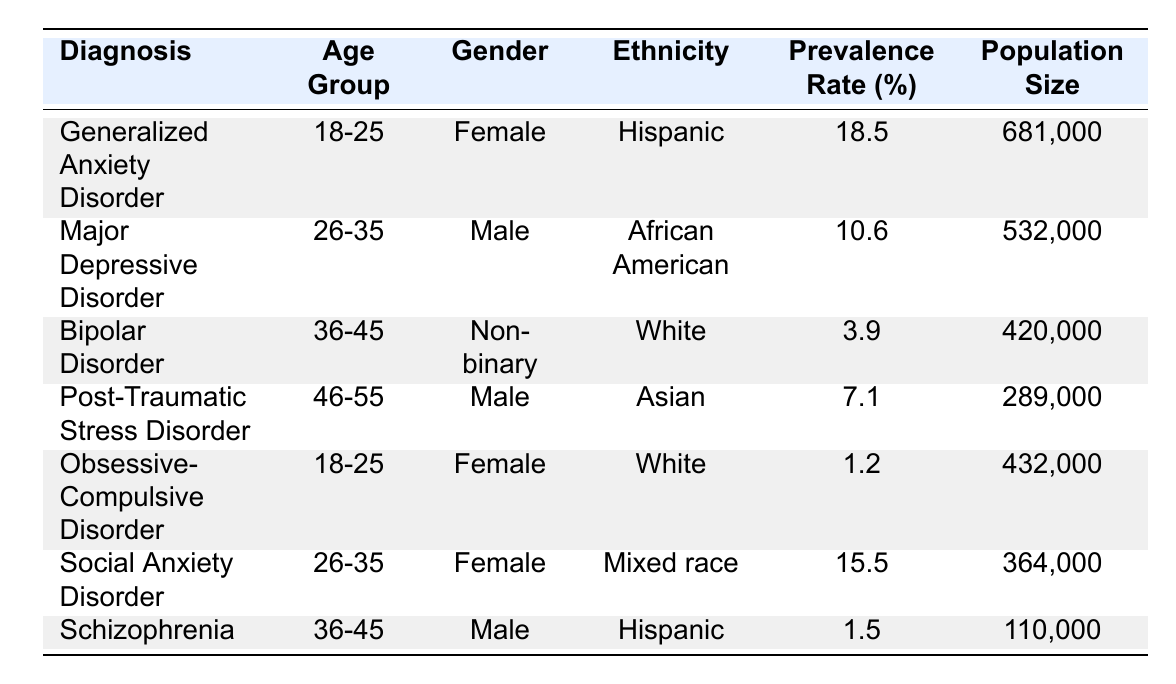What is the prevalence rate for Generalized Anxiety Disorder? The prevalence rate for Generalized Anxiety Disorder can be found in the table under the "Prevalence Rate (%)" column for the corresponding diagnosis. It shows as 18.5% for the age group 18-25, female, Hispanic population.
Answer: 18.5% How many individuals are diagnosed with Major Depressive Disorder in the 26-35 age group? The table indicates a population size of 532,000 individuals diagnosed with Major Depressive Disorder, which is listed under the specific demographics of age 26-35, male, African American.
Answer: 532,000 Is there a higher prevalence rate for Social Anxiety Disorder compared to Bipolar Disorder? By comparing the prevalence rates in the table, Social Anxiety Disorder has a prevalence rate of 15.5% while Bipolar Disorder has a prevalence rate of 3.9%. Therefore, the prevalence rate for Social Anxiety Disorder is higher.
Answer: Yes What is the total prevalence rate of anxiety disorders listed in the table? The identified anxiety disorders from the table are Generalized Anxiety Disorder (18.5%) and Social Anxiety Disorder (15.5%). To find the total prevalence rate, we sum these rates: 18.5 + 15.5 = 34%.
Answer: 34% What is the minimum population size for the diagnoses presented in the table? By examining the "Population Size" column, the values range from 110,000 (Schizophrenia) to 681,000 (Generalized Anxiety Disorder). The minimum value is 110,000.
Answer: 110,000 What percentage of population size does Obsessive-Compulsive Disorder represent compared to Major Depressive Disorder? The population sizes for Obsessive-Compulsive Disorder is 432,000 and for Major Depressive Disorder is 532,000. To find the percentage representation: (432,000 / 532,000) * 100 = 81.2%.
Answer: 81.2% Are there any diagnoses within the gender category "Female" that have a prevalence rate higher than 10%? The table contains diagnoses for females, which include Generalized Anxiety Disorder (18.5%) and Social Anxiety Disorder (15.5%). Both are above 10%, therefore there are diagnoses within this category that exceed that threshold.
Answer: Yes What age group accounts for the highest prevalence rate for any diagnosed mental health condition? Searching through the "Prevalence Rate (%)" column, Generalized Anxiety Disorder in the 18-25 age group (18.5%) is the highest recorded prevalence rate among all age groups.
Answer: 18-25 What is the difference in prevalence rates between Major Depressive Disorder and Post-Traumatic Stress Disorder? The prevalence rate for Major Depressive Disorder is 10.6% and for Post-Traumatic Stress Disorder, it is 7.1%. To find the difference: 10.6 - 7.1 = 3.5%.
Answer: 3.5% 